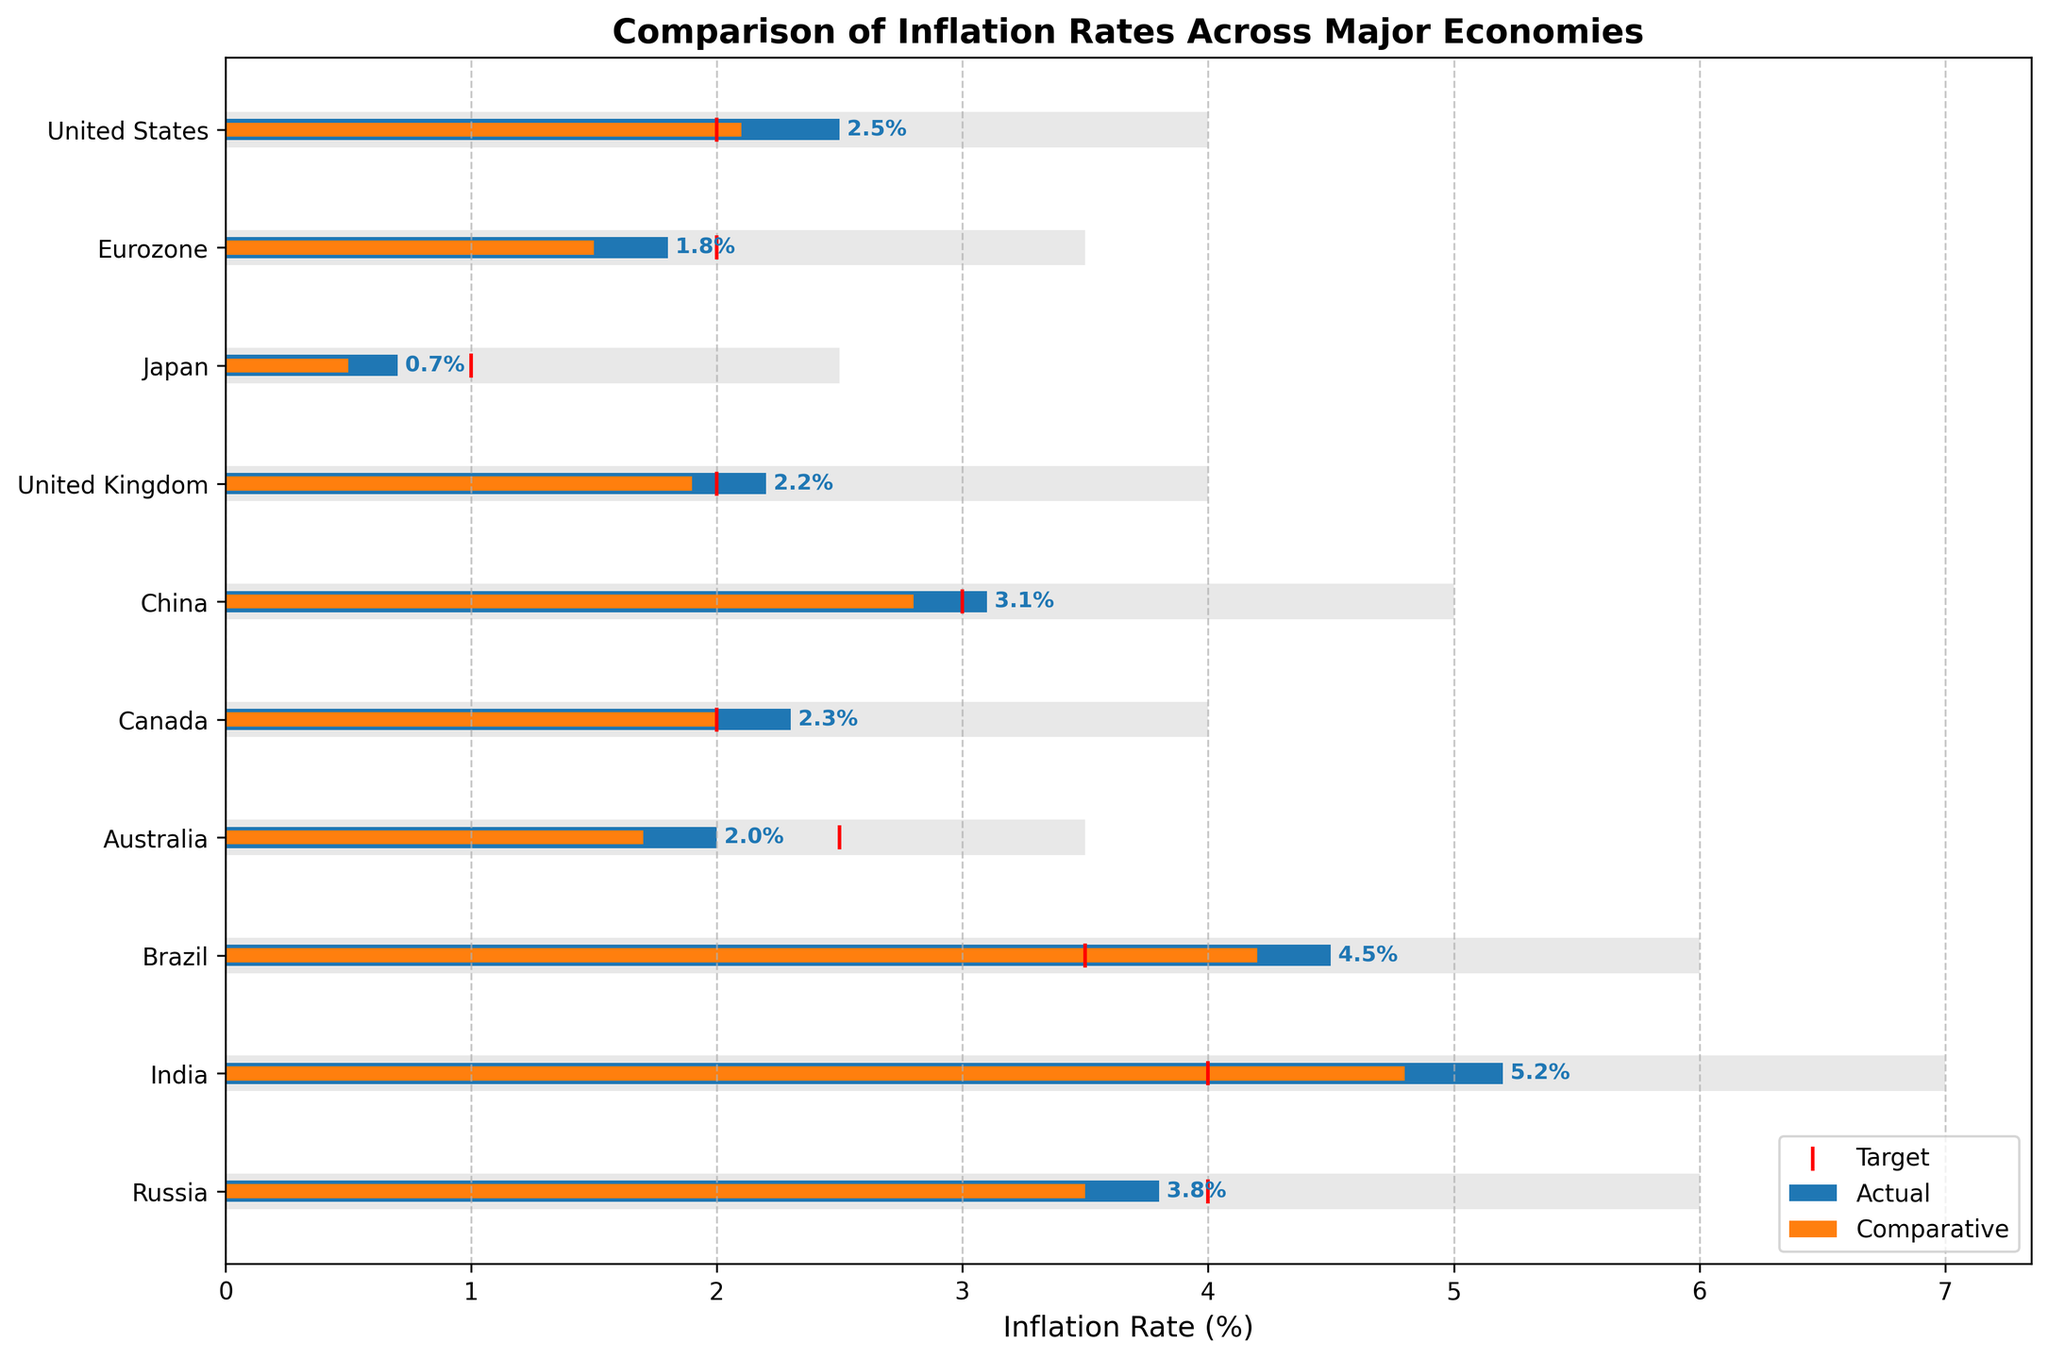What is the title of the chart? The title is displayed prominently at the top of the chart. It summarizes the content of the chart in a few words.
Answer: Comparison of Inflation Rates Across Major Economies Which country has the highest actual inflation rate? To find the highest actual inflation rate, you look for the tallest blue bar among the countries.
Answer: India What is the target inflation rate for Brazil? The target inflation rate is shown as a red vertical line for each country. Look at the position of this line for Brazil.
Answer: 3.5% How does the actual inflation rate in the United States compare with its target? Compare the length of the blue bar (actual) with the position of the red vertical line (target) for the United States. The blue bar extends slightly beyond the red line.
Answer: Higher Which country has an actual inflation rate closest to its target? Measure the distance between the blue bar and the red vertical line for each country. The country with the smallest gap between these two indicators has an actual rate closest to its target.
Answer: Australia What is the range of possible inflation rates for the Eurozone? The range of possible inflation rates is visually represented by the grey bar for each country. For the Eurozone, this grey bar extends from the start to the end values given in the dataset.
Answer: 0% to 3.5% Compare the actual inflation rate between China and Canada. Which one is higher, and by how much? Look at the blue bars for China and Canada. The length of China’s bar is 3.1%, and Canada’s is 2.3%. Subtract the two values to find the difference.
Answer: China is higher by 0.8% Which country has the widest range of possible inflation rates? The widest range is indicated by the longest grey bar for each country. Doubling the given range end value can also help identify the country.
Answer: India What is the average actual inflation rate across all listed countries? Sum all the actual inflation rates, then divide by the number of countries: (2.5 + 1.8 + 0.7 + 2.2 + 3.1 + 2.3 + 2.0 + 4.5 + 5.2 + 3.8) ÷ 10 = 2.81%
Answer: 2.81% How does the comparative inflation rate of the United Kingdom compare to that of Japan? Look at the orange bars for both countries. The length of the UK's bar is 1.9%, and Japan's is 0.5%. The UK’s rate is higher.
Answer: The UK’s rate is higher than Japan’s 